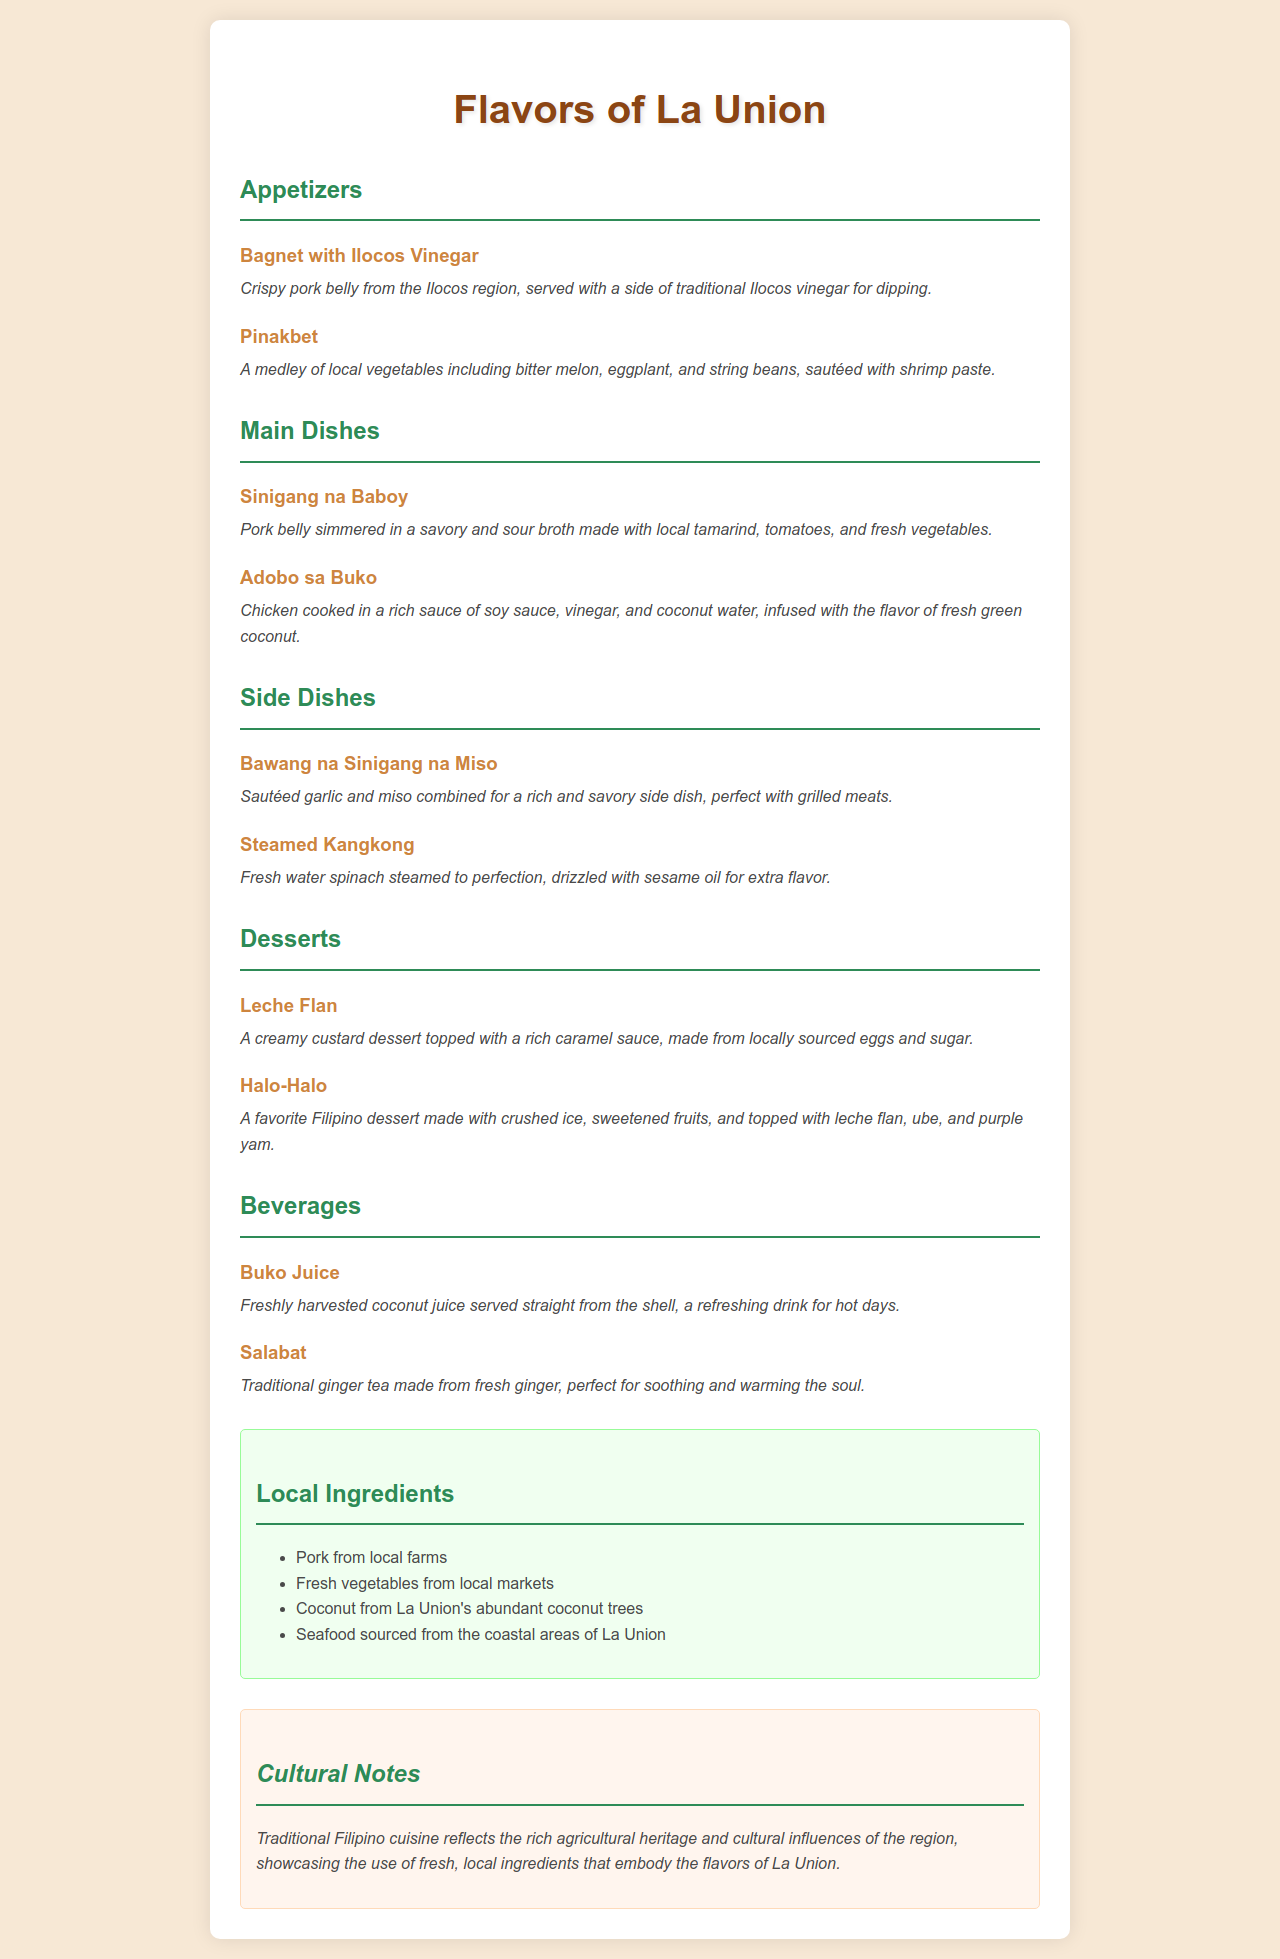what is the name of the first appetizer? The first appetizer listed is "Bagnet with Ilocos Vinegar."
Answer: Bagnet with Ilocos Vinegar which dish contains local tamarind? The dish "Sinigang na Baboy" is made with local tamarind.
Answer: Sinigang na Baboy how many side dishes are listed on the menu? There are two side dishes mentioned, which are "Bawang na Sinigang na Miso" and "Steamed Kangkong."
Answer: 2 what beverage is made from fresh ginger? The beverage made from fresh ginger is "Salabat."
Answer: Salabat list one local ingredient used in the dishes. One of the local ingredients is "Coconut from La Union's abundant coconut trees."
Answer: Coconut from La Union's abundant coconut trees what is the total number of dessert options? There are two dessert options available: "Leche Flan" and "Halo-Halo."
Answer: 2 which main dish incorporates chicken? The main dish that incorporates chicken is "Adobo sa Buko."
Answer: Adobo sa Buko what type of cuisine is featured in this menu? The menu features Traditional Filipino cuisine.
Answer: Traditional Filipino cuisine 